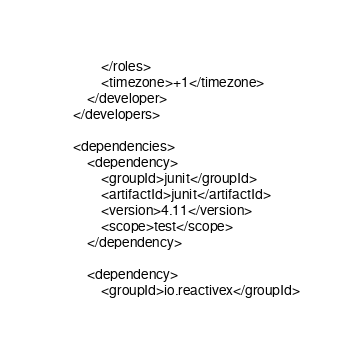Convert code to text. <code><loc_0><loc_0><loc_500><loc_500><_XML_>            </roles>
            <timezone>+1</timezone>
        </developer>
    </developers>

    <dependencies>
        <dependency>
            <groupId>junit</groupId>
            <artifactId>junit</artifactId>
            <version>4.11</version>
            <scope>test</scope>
        </dependency>

        <dependency>
            <groupId>io.reactivex</groupId></code> 